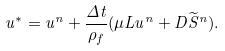<formula> <loc_0><loc_0><loc_500><loc_500>u ^ { * } = u ^ { n } + \frac { \Delta t } { \rho _ { f } } ( \mu L u ^ { n } + D \widetilde { S } ^ { n } ) .</formula> 